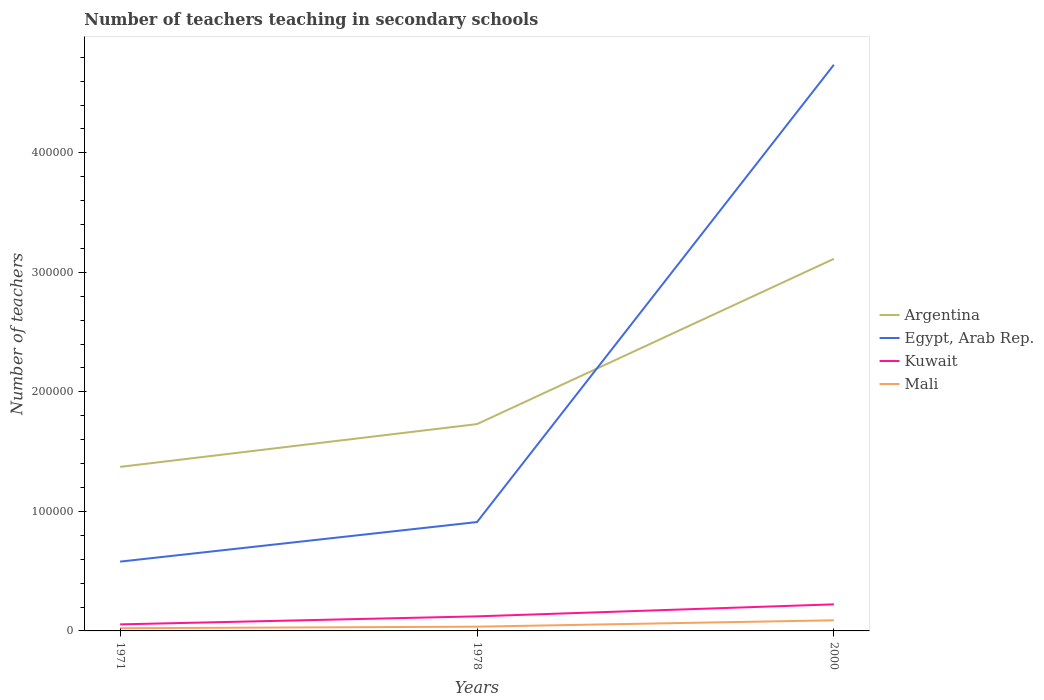How many different coloured lines are there?
Ensure brevity in your answer.  4. Across all years, what is the maximum number of teachers teaching in secondary schools in Kuwait?
Offer a terse response. 5476. In which year was the number of teachers teaching in secondary schools in Mali maximum?
Keep it short and to the point. 1971. What is the total number of teachers teaching in secondary schools in Egypt, Arab Rep. in the graph?
Ensure brevity in your answer.  -3.31e+04. What is the difference between the highest and the second highest number of teachers teaching in secondary schools in Kuwait?
Ensure brevity in your answer.  1.68e+04. How many lines are there?
Make the answer very short. 4. Are the values on the major ticks of Y-axis written in scientific E-notation?
Give a very brief answer. No. Does the graph contain grids?
Keep it short and to the point. No. How many legend labels are there?
Offer a very short reply. 4. How are the legend labels stacked?
Your answer should be compact. Vertical. What is the title of the graph?
Give a very brief answer. Number of teachers teaching in secondary schools. What is the label or title of the Y-axis?
Offer a very short reply. Number of teachers. What is the Number of teachers in Argentina in 1971?
Provide a short and direct response. 1.37e+05. What is the Number of teachers in Egypt, Arab Rep. in 1971?
Keep it short and to the point. 5.80e+04. What is the Number of teachers of Kuwait in 1971?
Your answer should be very brief. 5476. What is the Number of teachers of Mali in 1971?
Your answer should be compact. 2242. What is the Number of teachers of Argentina in 1978?
Your answer should be compact. 1.73e+05. What is the Number of teachers in Egypt, Arab Rep. in 1978?
Make the answer very short. 9.11e+04. What is the Number of teachers of Kuwait in 1978?
Ensure brevity in your answer.  1.22e+04. What is the Number of teachers in Mali in 1978?
Provide a succinct answer. 3555. What is the Number of teachers in Argentina in 2000?
Provide a succinct answer. 3.11e+05. What is the Number of teachers of Egypt, Arab Rep. in 2000?
Your answer should be compact. 4.74e+05. What is the Number of teachers in Kuwait in 2000?
Keep it short and to the point. 2.22e+04. What is the Number of teachers in Mali in 2000?
Your answer should be compact. 8899. Across all years, what is the maximum Number of teachers in Argentina?
Keep it short and to the point. 3.11e+05. Across all years, what is the maximum Number of teachers in Egypt, Arab Rep.?
Provide a succinct answer. 4.74e+05. Across all years, what is the maximum Number of teachers of Kuwait?
Give a very brief answer. 2.22e+04. Across all years, what is the maximum Number of teachers of Mali?
Ensure brevity in your answer.  8899. Across all years, what is the minimum Number of teachers in Argentina?
Provide a succinct answer. 1.37e+05. Across all years, what is the minimum Number of teachers of Egypt, Arab Rep.?
Provide a short and direct response. 5.80e+04. Across all years, what is the minimum Number of teachers of Kuwait?
Your answer should be very brief. 5476. Across all years, what is the minimum Number of teachers in Mali?
Keep it short and to the point. 2242. What is the total Number of teachers in Argentina in the graph?
Ensure brevity in your answer.  6.22e+05. What is the total Number of teachers in Egypt, Arab Rep. in the graph?
Provide a short and direct response. 6.23e+05. What is the total Number of teachers of Kuwait in the graph?
Keep it short and to the point. 3.99e+04. What is the total Number of teachers of Mali in the graph?
Your answer should be compact. 1.47e+04. What is the difference between the Number of teachers in Argentina in 1971 and that in 1978?
Keep it short and to the point. -3.58e+04. What is the difference between the Number of teachers of Egypt, Arab Rep. in 1971 and that in 1978?
Provide a short and direct response. -3.31e+04. What is the difference between the Number of teachers of Kuwait in 1971 and that in 1978?
Offer a very short reply. -6711. What is the difference between the Number of teachers in Mali in 1971 and that in 1978?
Give a very brief answer. -1313. What is the difference between the Number of teachers in Argentina in 1971 and that in 2000?
Provide a succinct answer. -1.74e+05. What is the difference between the Number of teachers of Egypt, Arab Rep. in 1971 and that in 2000?
Offer a very short reply. -4.16e+05. What is the difference between the Number of teachers of Kuwait in 1971 and that in 2000?
Your response must be concise. -1.68e+04. What is the difference between the Number of teachers of Mali in 1971 and that in 2000?
Your response must be concise. -6657. What is the difference between the Number of teachers of Argentina in 1978 and that in 2000?
Provide a succinct answer. -1.38e+05. What is the difference between the Number of teachers in Egypt, Arab Rep. in 1978 and that in 2000?
Your answer should be compact. -3.83e+05. What is the difference between the Number of teachers in Kuwait in 1978 and that in 2000?
Provide a succinct answer. -1.01e+04. What is the difference between the Number of teachers of Mali in 1978 and that in 2000?
Offer a terse response. -5344. What is the difference between the Number of teachers of Argentina in 1971 and the Number of teachers of Egypt, Arab Rep. in 1978?
Your answer should be compact. 4.62e+04. What is the difference between the Number of teachers of Argentina in 1971 and the Number of teachers of Kuwait in 1978?
Make the answer very short. 1.25e+05. What is the difference between the Number of teachers in Argentina in 1971 and the Number of teachers in Mali in 1978?
Offer a very short reply. 1.34e+05. What is the difference between the Number of teachers in Egypt, Arab Rep. in 1971 and the Number of teachers in Kuwait in 1978?
Give a very brief answer. 4.58e+04. What is the difference between the Number of teachers of Egypt, Arab Rep. in 1971 and the Number of teachers of Mali in 1978?
Offer a very short reply. 5.44e+04. What is the difference between the Number of teachers of Kuwait in 1971 and the Number of teachers of Mali in 1978?
Your response must be concise. 1921. What is the difference between the Number of teachers of Argentina in 1971 and the Number of teachers of Egypt, Arab Rep. in 2000?
Your answer should be compact. -3.36e+05. What is the difference between the Number of teachers of Argentina in 1971 and the Number of teachers of Kuwait in 2000?
Give a very brief answer. 1.15e+05. What is the difference between the Number of teachers of Argentina in 1971 and the Number of teachers of Mali in 2000?
Your answer should be compact. 1.28e+05. What is the difference between the Number of teachers in Egypt, Arab Rep. in 1971 and the Number of teachers in Kuwait in 2000?
Give a very brief answer. 3.57e+04. What is the difference between the Number of teachers of Egypt, Arab Rep. in 1971 and the Number of teachers of Mali in 2000?
Ensure brevity in your answer.  4.91e+04. What is the difference between the Number of teachers of Kuwait in 1971 and the Number of teachers of Mali in 2000?
Make the answer very short. -3423. What is the difference between the Number of teachers in Argentina in 1978 and the Number of teachers in Egypt, Arab Rep. in 2000?
Your answer should be compact. -3.01e+05. What is the difference between the Number of teachers in Argentina in 1978 and the Number of teachers in Kuwait in 2000?
Provide a succinct answer. 1.51e+05. What is the difference between the Number of teachers of Argentina in 1978 and the Number of teachers of Mali in 2000?
Your response must be concise. 1.64e+05. What is the difference between the Number of teachers of Egypt, Arab Rep. in 1978 and the Number of teachers of Kuwait in 2000?
Ensure brevity in your answer.  6.88e+04. What is the difference between the Number of teachers of Egypt, Arab Rep. in 1978 and the Number of teachers of Mali in 2000?
Your answer should be compact. 8.22e+04. What is the difference between the Number of teachers in Kuwait in 1978 and the Number of teachers in Mali in 2000?
Ensure brevity in your answer.  3288. What is the average Number of teachers of Argentina per year?
Your response must be concise. 2.07e+05. What is the average Number of teachers in Egypt, Arab Rep. per year?
Give a very brief answer. 2.08e+05. What is the average Number of teachers in Kuwait per year?
Keep it short and to the point. 1.33e+04. What is the average Number of teachers in Mali per year?
Your answer should be compact. 4898.67. In the year 1971, what is the difference between the Number of teachers in Argentina and Number of teachers in Egypt, Arab Rep.?
Provide a succinct answer. 7.93e+04. In the year 1971, what is the difference between the Number of teachers of Argentina and Number of teachers of Kuwait?
Provide a succinct answer. 1.32e+05. In the year 1971, what is the difference between the Number of teachers in Argentina and Number of teachers in Mali?
Your answer should be compact. 1.35e+05. In the year 1971, what is the difference between the Number of teachers of Egypt, Arab Rep. and Number of teachers of Kuwait?
Ensure brevity in your answer.  5.25e+04. In the year 1971, what is the difference between the Number of teachers in Egypt, Arab Rep. and Number of teachers in Mali?
Ensure brevity in your answer.  5.57e+04. In the year 1971, what is the difference between the Number of teachers of Kuwait and Number of teachers of Mali?
Make the answer very short. 3234. In the year 1978, what is the difference between the Number of teachers of Argentina and Number of teachers of Egypt, Arab Rep.?
Your answer should be very brief. 8.20e+04. In the year 1978, what is the difference between the Number of teachers in Argentina and Number of teachers in Kuwait?
Offer a very short reply. 1.61e+05. In the year 1978, what is the difference between the Number of teachers in Argentina and Number of teachers in Mali?
Your response must be concise. 1.69e+05. In the year 1978, what is the difference between the Number of teachers of Egypt, Arab Rep. and Number of teachers of Kuwait?
Offer a very short reply. 7.89e+04. In the year 1978, what is the difference between the Number of teachers in Egypt, Arab Rep. and Number of teachers in Mali?
Your response must be concise. 8.75e+04. In the year 1978, what is the difference between the Number of teachers in Kuwait and Number of teachers in Mali?
Give a very brief answer. 8632. In the year 2000, what is the difference between the Number of teachers in Argentina and Number of teachers in Egypt, Arab Rep.?
Give a very brief answer. -1.62e+05. In the year 2000, what is the difference between the Number of teachers of Argentina and Number of teachers of Kuwait?
Make the answer very short. 2.89e+05. In the year 2000, what is the difference between the Number of teachers in Argentina and Number of teachers in Mali?
Offer a terse response. 3.02e+05. In the year 2000, what is the difference between the Number of teachers in Egypt, Arab Rep. and Number of teachers in Kuwait?
Your answer should be compact. 4.51e+05. In the year 2000, what is the difference between the Number of teachers in Egypt, Arab Rep. and Number of teachers in Mali?
Your response must be concise. 4.65e+05. In the year 2000, what is the difference between the Number of teachers in Kuwait and Number of teachers in Mali?
Offer a very short reply. 1.33e+04. What is the ratio of the Number of teachers of Argentina in 1971 to that in 1978?
Offer a terse response. 0.79. What is the ratio of the Number of teachers of Egypt, Arab Rep. in 1971 to that in 1978?
Offer a very short reply. 0.64. What is the ratio of the Number of teachers in Kuwait in 1971 to that in 1978?
Provide a succinct answer. 0.45. What is the ratio of the Number of teachers in Mali in 1971 to that in 1978?
Provide a short and direct response. 0.63. What is the ratio of the Number of teachers in Argentina in 1971 to that in 2000?
Your answer should be compact. 0.44. What is the ratio of the Number of teachers of Egypt, Arab Rep. in 1971 to that in 2000?
Provide a short and direct response. 0.12. What is the ratio of the Number of teachers of Kuwait in 1971 to that in 2000?
Your response must be concise. 0.25. What is the ratio of the Number of teachers in Mali in 1971 to that in 2000?
Provide a succinct answer. 0.25. What is the ratio of the Number of teachers of Argentina in 1978 to that in 2000?
Provide a short and direct response. 0.56. What is the ratio of the Number of teachers in Egypt, Arab Rep. in 1978 to that in 2000?
Your answer should be compact. 0.19. What is the ratio of the Number of teachers in Kuwait in 1978 to that in 2000?
Offer a terse response. 0.55. What is the ratio of the Number of teachers in Mali in 1978 to that in 2000?
Ensure brevity in your answer.  0.4. What is the difference between the highest and the second highest Number of teachers of Argentina?
Keep it short and to the point. 1.38e+05. What is the difference between the highest and the second highest Number of teachers of Egypt, Arab Rep.?
Keep it short and to the point. 3.83e+05. What is the difference between the highest and the second highest Number of teachers in Kuwait?
Your answer should be very brief. 1.01e+04. What is the difference between the highest and the second highest Number of teachers of Mali?
Make the answer very short. 5344. What is the difference between the highest and the lowest Number of teachers in Argentina?
Your answer should be compact. 1.74e+05. What is the difference between the highest and the lowest Number of teachers of Egypt, Arab Rep.?
Keep it short and to the point. 4.16e+05. What is the difference between the highest and the lowest Number of teachers in Kuwait?
Keep it short and to the point. 1.68e+04. What is the difference between the highest and the lowest Number of teachers of Mali?
Provide a short and direct response. 6657. 